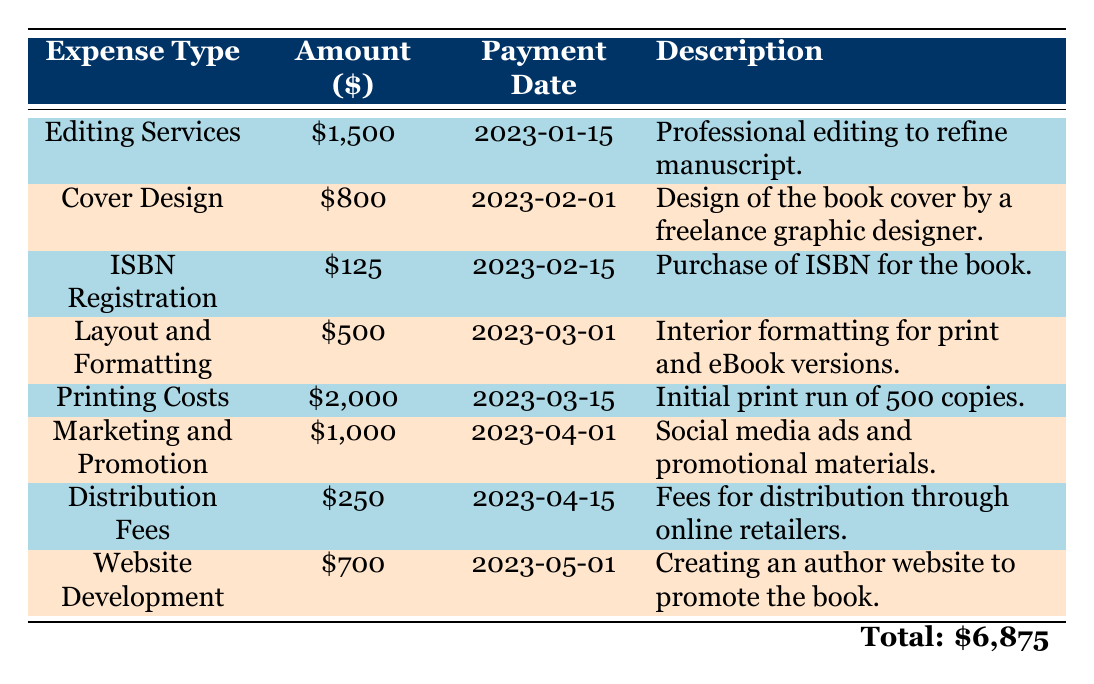What is the total amount spent on all publishing expenses? To find the total amount, we sum up all individual expenses: 1500 (Editing) + 800 (Cover Design) + 125 (ISBN) + 500 (Layout) + 2000 (Printing) + 1000 (Marketing) + 250 (Distribution) + 700 (Website) = 6875.
Answer: 6875 When was the payment for cover design made? Referring to the table, the payment date for Cover Design is indicated as 2023-02-01.
Answer: 2023-02-01 Which expense has the highest cost? By checking the amount column, Printing Costs has the highest expense at 2000.
Answer: Printing Costs What is the average cost of the publishing expenses? The total amount spent is 6875, and there are 8 expenses, so the average is 6875 divided by 8, which equals 859.375.
Answer: 859.375 Is the payment for ISBN registration higher than that for website development? Looking at the amounts, ISBN Registration is 125, while Website Development is 700. Since 125 is less than 700, the statement is false.
Answer: No How much more was spent on Marketing and Promotion than on Distribution Fees? The expense for Marketing and Promotion is 1000, and for Distribution Fees, it is 250. The difference is calculated by 1000 - 250 = 750.
Answer: 750 What percentage of the total expenses were spent on Editing Services? Editing Services costs 1500 and the total expenses are 6875. To find the percentage, we calculate (1500 / 6875) * 100, which equals approximately 21.82%.
Answer: 21.82% Was any expense related to social media ads? The table lists Marketing and Promotion as an expense, which mentions social media ads and promotional materials, confirming that yes, there was an expense related to it.
Answer: Yes How many expenses exceeded $500 in cost? By reviewing the amounts, the expenses exceeding $500 are Editing Services (1500), Cover Design (800), Printing Costs (2000), and Marketing and Promotion (1000). That's a total of 4 expenses.
Answer: 4 